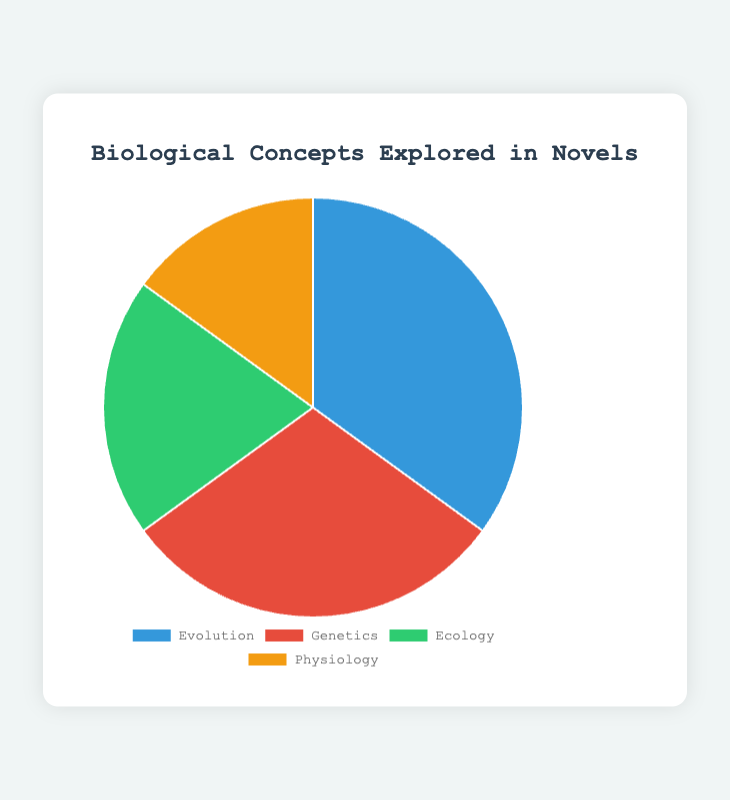Which concept is explored the most in novels? The pie chart shows the distribution of biological concepts explored in novels. The largest segment in the pie chart represents Evolution.
Answer: Evolution Which concept is explored the least in novels? The smallest segment in the pie chart represents Physiology at 15%.
Answer: Physiology What is the combined percentage for Ecology and Physiology? Ecology has 20% and Physiology has 15%. The combined percentage is 20 + 15 = 35%.
Answer: 35% How does the percentage of Genetics compare to Ecology? Genetics has a percentage of 30% while Ecology has 20%. Genetics is 10% higher than Ecology.
Answer: 10% higher What two concepts combined make up the same percentage as Evolution? Evolution is 35%. Combining Ecology (20%) and Physiology (15%) gives 20 + 15 = 35%.
Answer: Ecology and Physiology If you were to rank the concepts from most to least frequently explored, what would be the order? Based on the percentages, the order from most to least is: Evolution (35%), Genetics (30%), Ecology (20%), Physiology (15%).
Answer: Evolution, Genetics, Ecology, Physiology Which segment is represented by the color green? The pie chart has segments colored blue, red, green, and orange. Ecology is represented by green.
Answer: Ecology By how many percentage points does Evolution exceed Physiology? Evolution has 35% and Physiology has 15%. The difference is 35 - 15 = 20 percentage points.
Answer: 20 percentage points How much more popular is Genetics compared to Physiology? Genetics has 30% while Physiology has 15%. The difference is 30 - 15 = 15%.
Answer: 15% What percentage of novels explore concepts related to Evolution and Genetics together? Evolution has 35% and Genetics has 30%. Together, they make up 35 + 30 = 65% of the novels.
Answer: 65% 